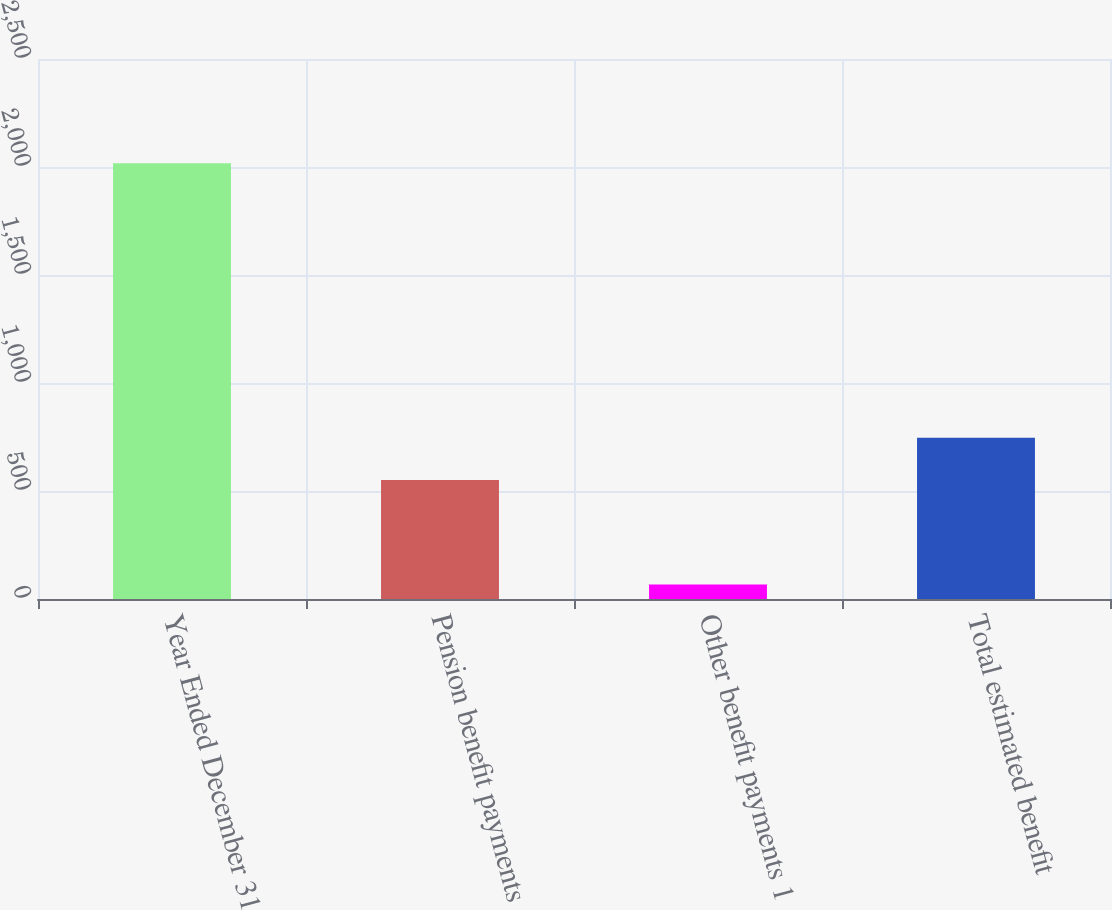<chart> <loc_0><loc_0><loc_500><loc_500><bar_chart><fcel>Year Ended December 31<fcel>Pension benefit payments<fcel>Other benefit payments 1<fcel>Total estimated benefit<nl><fcel>2017<fcel>551<fcel>67<fcel>746<nl></chart> 